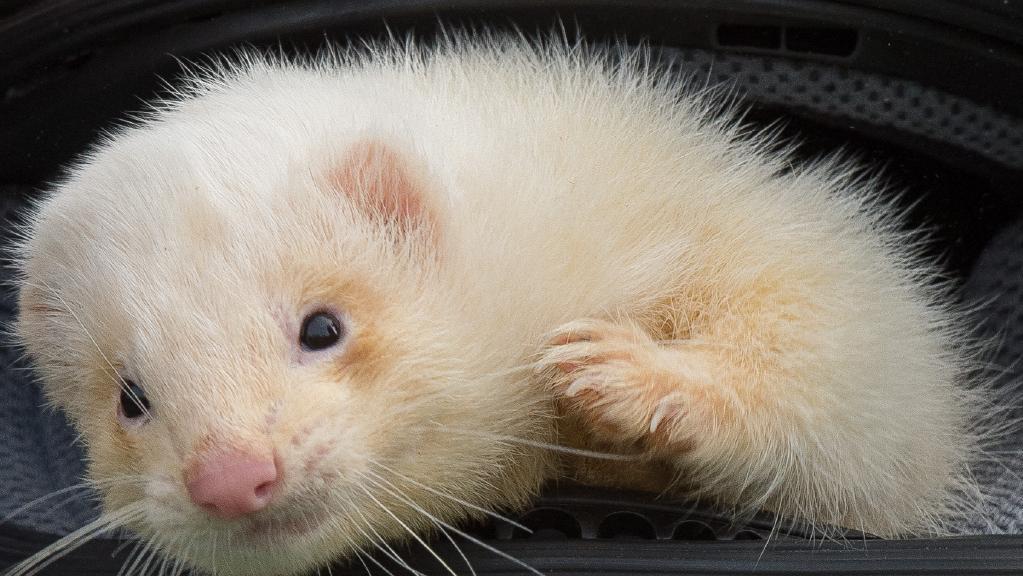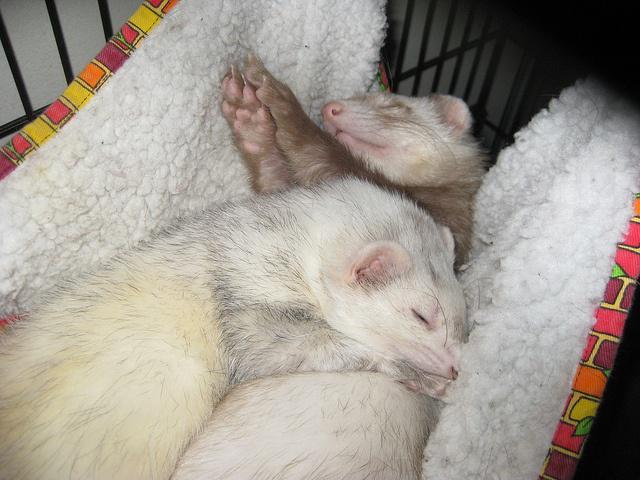The first image is the image on the left, the second image is the image on the right. Assess this claim about the two images: "The right image contains twice as many ferrets as the left image.". Correct or not? Answer yes or no. Yes. The first image is the image on the left, the second image is the image on the right. Assess this claim about the two images: "The right image contains exactly one ferret.". Correct or not? Answer yes or no. No. 